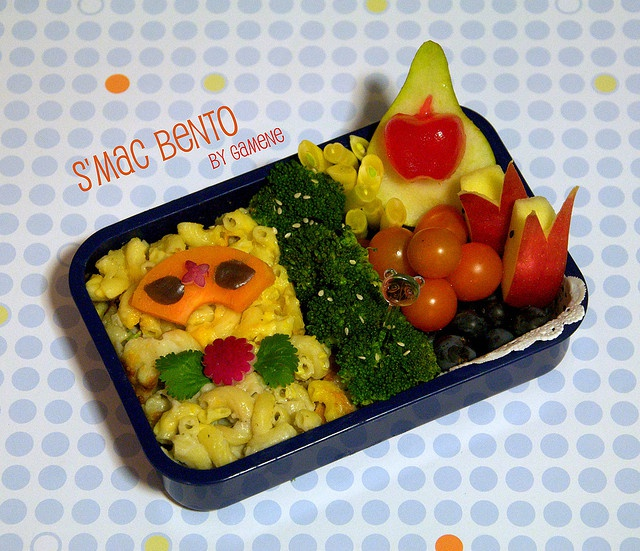Describe the objects in this image and their specific colors. I can see bowl in darkgray, black, brown, gold, and olive tones, broccoli in darkgray, black, darkgreen, and olive tones, apple in darkgray, maroon, brown, and black tones, carrot in darkgray, red, maroon, and orange tones, and apple in darkgray, brown, and red tones in this image. 